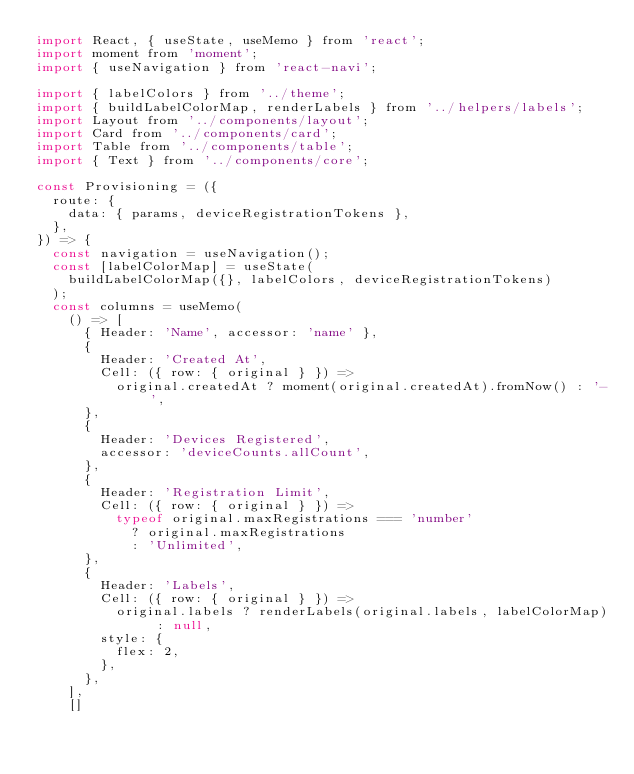Convert code to text. <code><loc_0><loc_0><loc_500><loc_500><_JavaScript_>import React, { useState, useMemo } from 'react';
import moment from 'moment';
import { useNavigation } from 'react-navi';

import { labelColors } from '../theme';
import { buildLabelColorMap, renderLabels } from '../helpers/labels';
import Layout from '../components/layout';
import Card from '../components/card';
import Table from '../components/table';
import { Text } from '../components/core';

const Provisioning = ({
  route: {
    data: { params, deviceRegistrationTokens },
  },
}) => {
  const navigation = useNavigation();
  const [labelColorMap] = useState(
    buildLabelColorMap({}, labelColors, deviceRegistrationTokens)
  );
  const columns = useMemo(
    () => [
      { Header: 'Name', accessor: 'name' },
      {
        Header: 'Created At',
        Cell: ({ row: { original } }) =>
          original.createdAt ? moment(original.createdAt).fromNow() : '-',
      },
      {
        Header: 'Devices Registered',
        accessor: 'deviceCounts.allCount',
      },
      {
        Header: 'Registration Limit',
        Cell: ({ row: { original } }) =>
          typeof original.maxRegistrations === 'number'
            ? original.maxRegistrations
            : 'Unlimited',
      },
      {
        Header: 'Labels',
        Cell: ({ row: { original } }) =>
          original.labels ? renderLabels(original.labels, labelColorMap) : null,
        style: {
          flex: 2,
        },
      },
    ],
    []</code> 